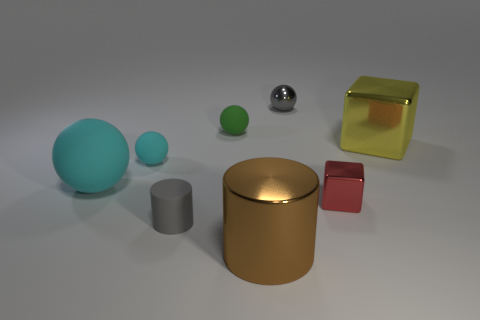Subtract all brown cubes. How many cyan balls are left? 2 Subtract 1 spheres. How many spheres are left? 3 Add 2 tiny cyan metallic spheres. How many objects exist? 10 Subtract all small balls. How many balls are left? 1 Subtract all yellow balls. Subtract all blue blocks. How many balls are left? 4 Subtract all blocks. How many objects are left? 6 Subtract all tiny gray shiny objects. Subtract all yellow cubes. How many objects are left? 6 Add 7 cubes. How many cubes are left? 9 Add 6 cyan matte spheres. How many cyan matte spheres exist? 8 Subtract 0 red balls. How many objects are left? 8 